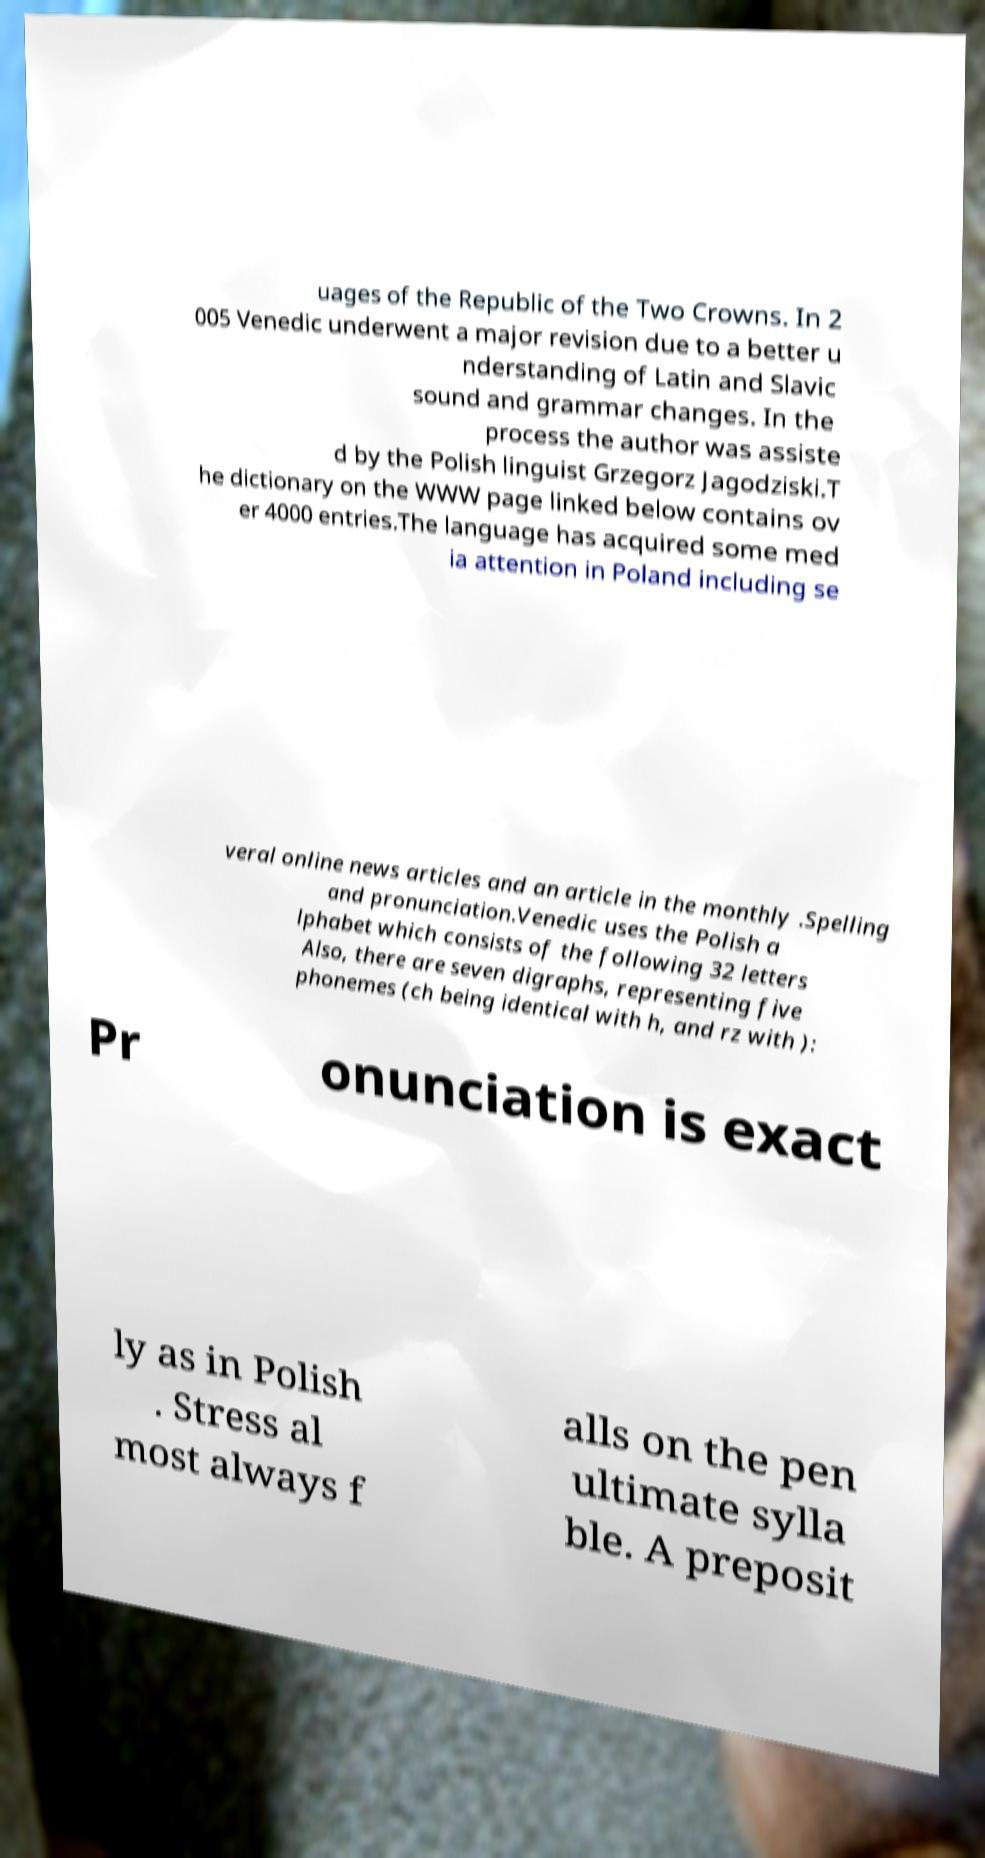What messages or text are displayed in this image? I need them in a readable, typed format. uages of the Republic of the Two Crowns. In 2 005 Venedic underwent a major revision due to a better u nderstanding of Latin and Slavic sound and grammar changes. In the process the author was assiste d by the Polish linguist Grzegorz Jagodziski.T he dictionary on the WWW page linked below contains ov er 4000 entries.The language has acquired some med ia attention in Poland including se veral online news articles and an article in the monthly .Spelling and pronunciation.Venedic uses the Polish a lphabet which consists of the following 32 letters Also, there are seven digraphs, representing five phonemes (ch being identical with h, and rz with ): Pr onunciation is exact ly as in Polish . Stress al most always f alls on the pen ultimate sylla ble. A preposit 